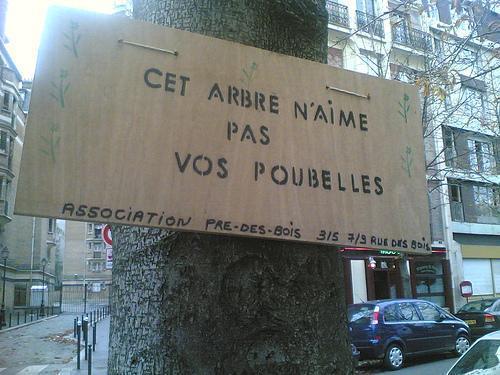How many cars are in the photo?
Give a very brief answer. 1. How many cats are sitting on the floor?
Give a very brief answer. 0. 